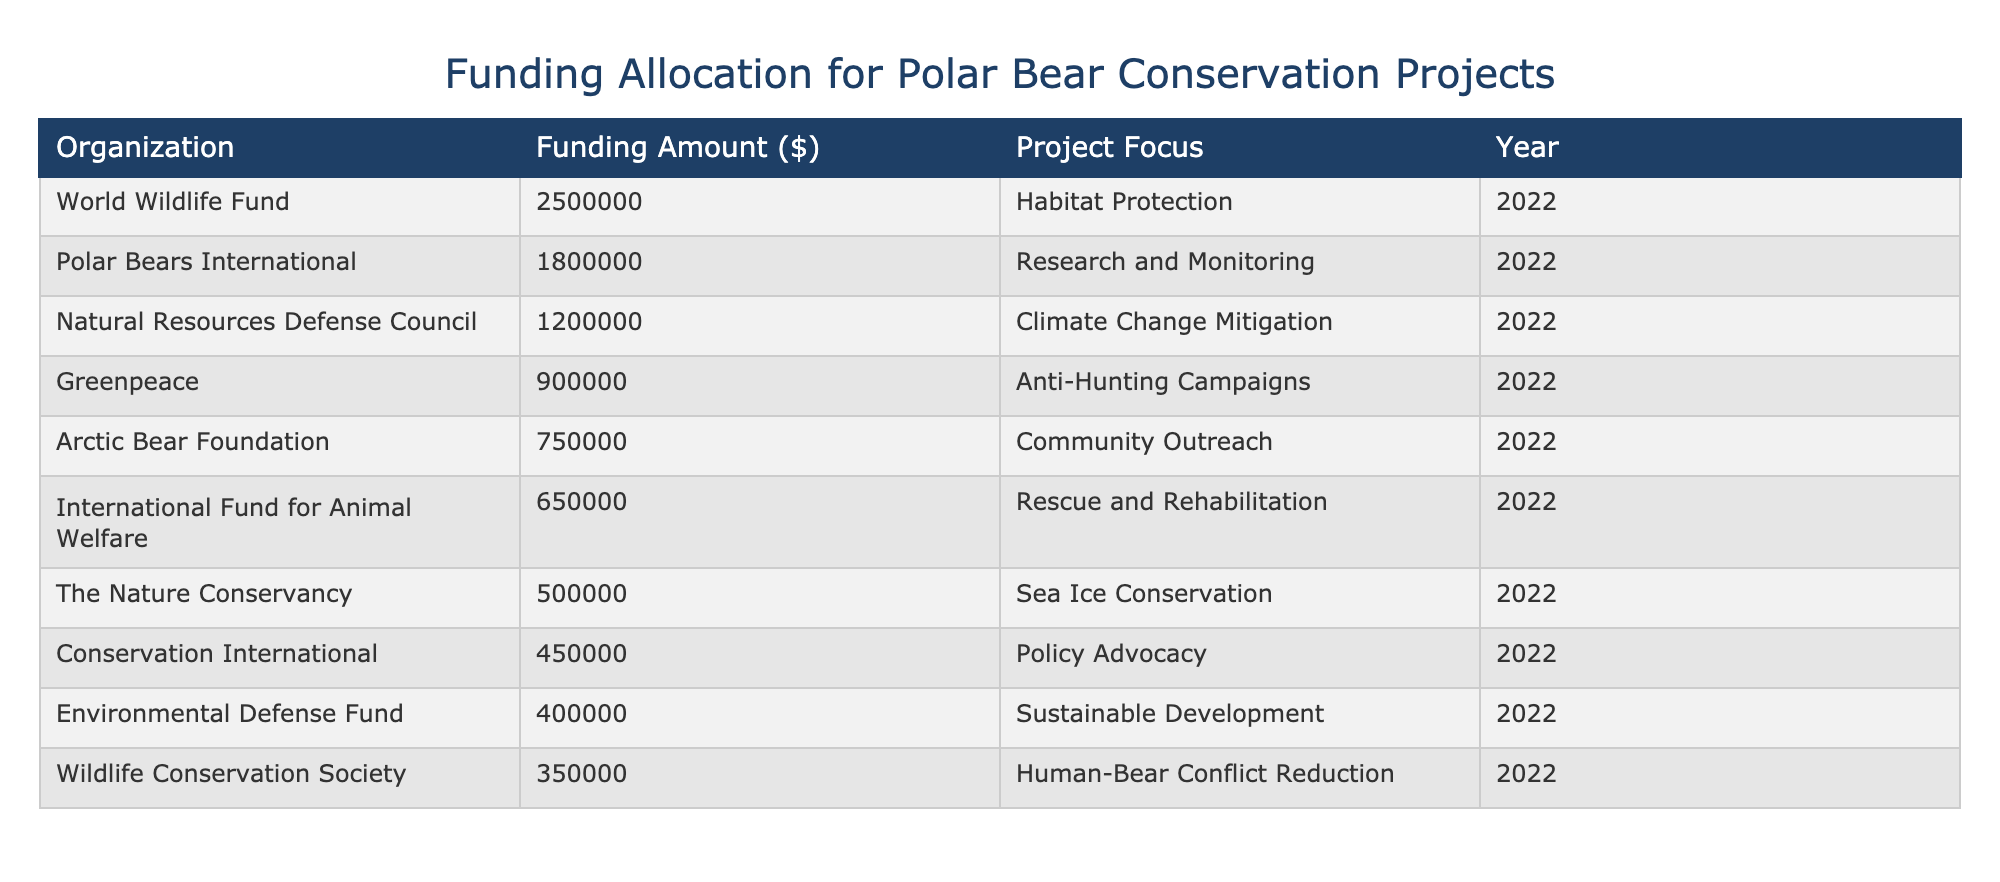What is the largest funding amount allocated to a single organization? The table indicates that the World Wildlife Fund received the highest funding amount of $2,500,000 for habitat protection in 2022.
Answer: 2,500,000 Which organization focused on climate change mitigation? According to the table, the Natural Resources Defense Council focused on climate change mitigation with a funding amount of $1,200,000.
Answer: Natural Resources Defense Council What was the total funding allocated for rescue and rehabilitation projects? The International Fund for Animal Welfare was the only organization listed with a focus on rescue and rehabilitation, receiving $650,000. Thus, the total funding for this category is $650,000.
Answer: 650,000 Are there any organizations that allocated more than $1,000,000 for anti-hunting campaigns? The table shows that Greenpeace received $900,000 for anti-hunting campaigns, which does not exceed $1,000,000. Therefore, the answer is no, there are no organizations that allocated more than $1,000,000 for this specific project focus.
Answer: No What is the combined funding amount for all organizations focusing on habitat protection and climate change mitigation? For habitat protection, the World Wildlife Fund received $2,500,000, and for climate change mitigation, the Natural Resources Defense Council received $1,200,000. The combined funding is $2,500,000 + $1,200,000 = $3,700,000.
Answer: 3,700,000 Which organization had the smallest funding amount for their project? The table lists the Wildlife Conservation Society with the smallest funding amount of $350,000 for human-bear conflict reduction.
Answer: Wildlife Conservation Society What percentage of the total funding does Polar Bears International receive? To find the percentage of the total funding attributed to Polar Bears International, first, sum up all funding amounts: $2,500,000 + $1,800,000 + $1,200,000 + $900,000 + $750,000 + $650,000 + $500,000 + $450,000 + $400,000 + $350,000 = $10,650,000. Then, divide Polar Bears International's funding ($1,800,000) by the total and multiply by 100: ($1,800,000 / $10,650,000) * 100 ≈ 16.9%.
Answer: 16.9% How many organizations focused on community outreach projects? The Arctic Bear Foundation is the only organization listed that focused on community outreach, with a funding amount of $750,000. Therefore, there is just one organization in this category.
Answer: 1 